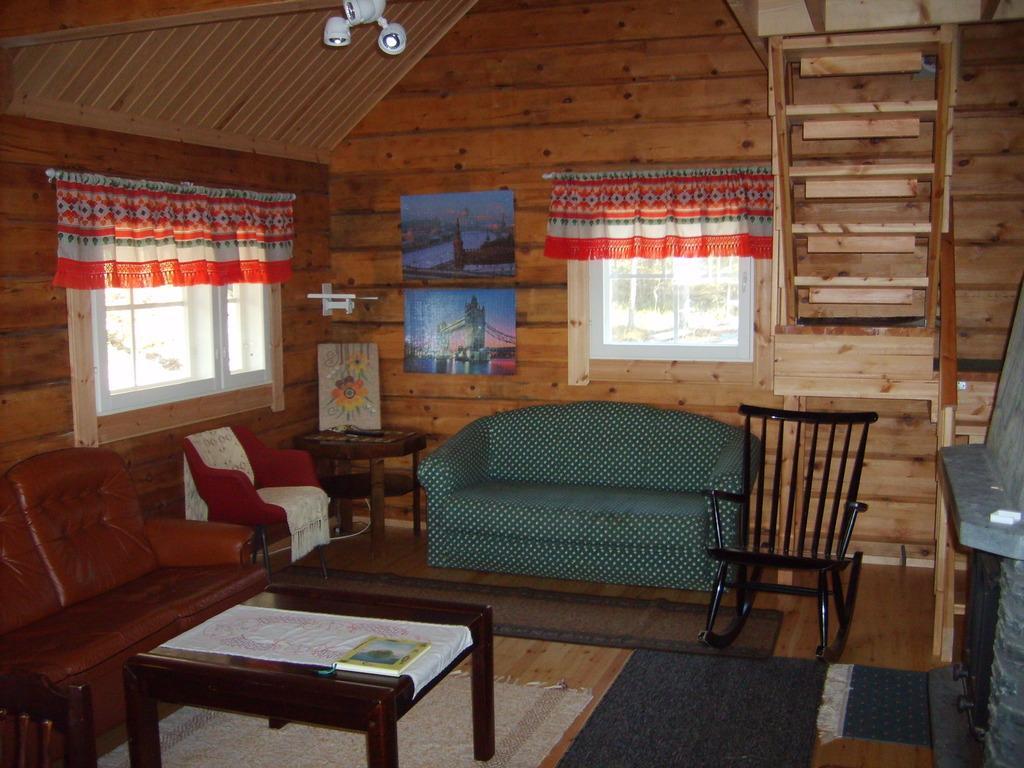Could you give a brief overview of what you see in this image? At the top of the picture we can see cc cameras. These are the windows. This is a floor carpet. here we can see a chair and a table. These are sofas. here we can see a table and on the table we can see a white cloth and a dairy. 